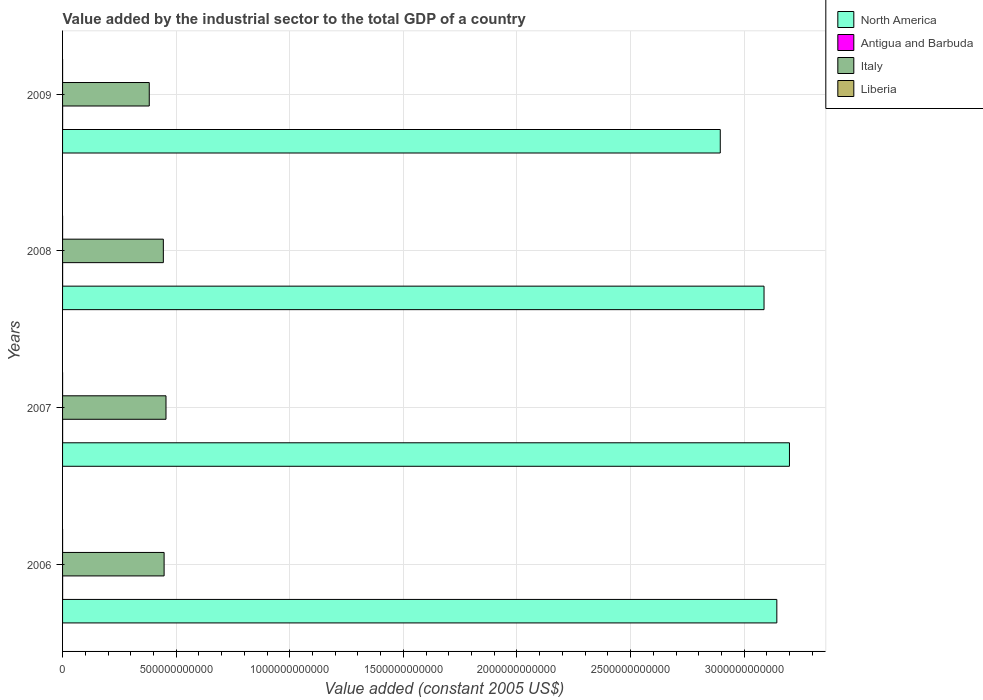How many different coloured bars are there?
Provide a short and direct response. 4. How many groups of bars are there?
Give a very brief answer. 4. Are the number of bars per tick equal to the number of legend labels?
Give a very brief answer. Yes. Are the number of bars on each tick of the Y-axis equal?
Your answer should be very brief. Yes. How many bars are there on the 1st tick from the top?
Make the answer very short. 4. What is the label of the 3rd group of bars from the top?
Offer a terse response. 2007. In how many cases, is the number of bars for a given year not equal to the number of legend labels?
Give a very brief answer. 0. What is the value added by the industrial sector in Liberia in 2009?
Your response must be concise. 5.75e+07. Across all years, what is the maximum value added by the industrial sector in Liberia?
Offer a very short reply. 6.25e+07. Across all years, what is the minimum value added by the industrial sector in Italy?
Ensure brevity in your answer.  3.82e+11. What is the total value added by the industrial sector in Liberia in the graph?
Offer a terse response. 2.19e+08. What is the difference between the value added by the industrial sector in North America in 2006 and that in 2009?
Your response must be concise. 2.49e+11. What is the difference between the value added by the industrial sector in Antigua and Barbuda in 2008 and the value added by the industrial sector in North America in 2007?
Make the answer very short. -3.20e+12. What is the average value added by the industrial sector in Italy per year?
Give a very brief answer. 4.32e+11. In the year 2006, what is the difference between the value added by the industrial sector in Antigua and Barbuda and value added by the industrial sector in Italy?
Give a very brief answer. -4.47e+11. In how many years, is the value added by the industrial sector in North America greater than 2400000000000 US$?
Keep it short and to the point. 4. What is the ratio of the value added by the industrial sector in Italy in 2007 to that in 2008?
Make the answer very short. 1.03. What is the difference between the highest and the second highest value added by the industrial sector in Antigua and Barbuda?
Make the answer very short. 7.64e+05. What is the difference between the highest and the lowest value added by the industrial sector in Italy?
Ensure brevity in your answer.  7.36e+1. In how many years, is the value added by the industrial sector in Italy greater than the average value added by the industrial sector in Italy taken over all years?
Provide a short and direct response. 3. What does the 1st bar from the top in 2008 represents?
Ensure brevity in your answer.  Liberia. What does the 3rd bar from the bottom in 2008 represents?
Your answer should be compact. Italy. How many bars are there?
Your response must be concise. 16. What is the difference between two consecutive major ticks on the X-axis?
Keep it short and to the point. 5.00e+11. Where does the legend appear in the graph?
Make the answer very short. Top right. What is the title of the graph?
Give a very brief answer. Value added by the industrial sector to the total GDP of a country. What is the label or title of the X-axis?
Your answer should be compact. Value added (constant 2005 US$). What is the label or title of the Y-axis?
Keep it short and to the point. Years. What is the Value added (constant 2005 US$) of North America in 2006?
Ensure brevity in your answer.  3.14e+12. What is the Value added (constant 2005 US$) of Antigua and Barbuda in 2006?
Ensure brevity in your answer.  2.01e+08. What is the Value added (constant 2005 US$) in Italy in 2006?
Make the answer very short. 4.47e+11. What is the Value added (constant 2005 US$) of Liberia in 2006?
Provide a short and direct response. 4.59e+07. What is the Value added (constant 2005 US$) of North America in 2007?
Make the answer very short. 3.20e+12. What is the Value added (constant 2005 US$) of Antigua and Barbuda in 2007?
Offer a very short reply. 2.17e+08. What is the Value added (constant 2005 US$) in Italy in 2007?
Make the answer very short. 4.55e+11. What is the Value added (constant 2005 US$) of Liberia in 2007?
Provide a succinct answer. 5.27e+07. What is the Value added (constant 2005 US$) of North America in 2008?
Provide a succinct answer. 3.09e+12. What is the Value added (constant 2005 US$) in Antigua and Barbuda in 2008?
Ensure brevity in your answer.  2.18e+08. What is the Value added (constant 2005 US$) in Italy in 2008?
Your answer should be very brief. 4.44e+11. What is the Value added (constant 2005 US$) in Liberia in 2008?
Ensure brevity in your answer.  6.25e+07. What is the Value added (constant 2005 US$) in North America in 2009?
Give a very brief answer. 2.89e+12. What is the Value added (constant 2005 US$) in Antigua and Barbuda in 2009?
Ensure brevity in your answer.  2.03e+08. What is the Value added (constant 2005 US$) in Italy in 2009?
Ensure brevity in your answer.  3.82e+11. What is the Value added (constant 2005 US$) of Liberia in 2009?
Give a very brief answer. 5.75e+07. Across all years, what is the maximum Value added (constant 2005 US$) in North America?
Provide a short and direct response. 3.20e+12. Across all years, what is the maximum Value added (constant 2005 US$) in Antigua and Barbuda?
Offer a terse response. 2.18e+08. Across all years, what is the maximum Value added (constant 2005 US$) of Italy?
Give a very brief answer. 4.55e+11. Across all years, what is the maximum Value added (constant 2005 US$) in Liberia?
Provide a short and direct response. 6.25e+07. Across all years, what is the minimum Value added (constant 2005 US$) in North America?
Your answer should be very brief. 2.89e+12. Across all years, what is the minimum Value added (constant 2005 US$) of Antigua and Barbuda?
Make the answer very short. 2.01e+08. Across all years, what is the minimum Value added (constant 2005 US$) of Italy?
Provide a short and direct response. 3.82e+11. Across all years, what is the minimum Value added (constant 2005 US$) of Liberia?
Your response must be concise. 4.59e+07. What is the total Value added (constant 2005 US$) in North America in the graph?
Offer a terse response. 1.23e+13. What is the total Value added (constant 2005 US$) in Antigua and Barbuda in the graph?
Give a very brief answer. 8.40e+08. What is the total Value added (constant 2005 US$) of Italy in the graph?
Your answer should be very brief. 1.73e+12. What is the total Value added (constant 2005 US$) of Liberia in the graph?
Your response must be concise. 2.19e+08. What is the difference between the Value added (constant 2005 US$) in North America in 2006 and that in 2007?
Keep it short and to the point. -5.56e+1. What is the difference between the Value added (constant 2005 US$) of Antigua and Barbuda in 2006 and that in 2007?
Ensure brevity in your answer.  -1.63e+07. What is the difference between the Value added (constant 2005 US$) of Italy in 2006 and that in 2007?
Provide a succinct answer. -8.29e+09. What is the difference between the Value added (constant 2005 US$) in Liberia in 2006 and that in 2007?
Provide a short and direct response. -6.78e+06. What is the difference between the Value added (constant 2005 US$) in North America in 2006 and that in 2008?
Your answer should be very brief. 5.63e+1. What is the difference between the Value added (constant 2005 US$) of Antigua and Barbuda in 2006 and that in 2008?
Offer a terse response. -1.71e+07. What is the difference between the Value added (constant 2005 US$) of Italy in 2006 and that in 2008?
Your answer should be compact. 3.36e+09. What is the difference between the Value added (constant 2005 US$) in Liberia in 2006 and that in 2008?
Your response must be concise. -1.66e+07. What is the difference between the Value added (constant 2005 US$) of North America in 2006 and that in 2009?
Offer a terse response. 2.49e+11. What is the difference between the Value added (constant 2005 US$) in Antigua and Barbuda in 2006 and that in 2009?
Provide a succinct answer. -2.17e+06. What is the difference between the Value added (constant 2005 US$) of Italy in 2006 and that in 2009?
Ensure brevity in your answer.  6.54e+1. What is the difference between the Value added (constant 2005 US$) of Liberia in 2006 and that in 2009?
Provide a succinct answer. -1.16e+07. What is the difference between the Value added (constant 2005 US$) in North America in 2007 and that in 2008?
Offer a terse response. 1.12e+11. What is the difference between the Value added (constant 2005 US$) in Antigua and Barbuda in 2007 and that in 2008?
Provide a succinct answer. -7.64e+05. What is the difference between the Value added (constant 2005 US$) of Italy in 2007 and that in 2008?
Your answer should be very brief. 1.17e+1. What is the difference between the Value added (constant 2005 US$) in Liberia in 2007 and that in 2008?
Offer a terse response. -9.85e+06. What is the difference between the Value added (constant 2005 US$) in North America in 2007 and that in 2009?
Give a very brief answer. 3.05e+11. What is the difference between the Value added (constant 2005 US$) of Antigua and Barbuda in 2007 and that in 2009?
Provide a short and direct response. 1.41e+07. What is the difference between the Value added (constant 2005 US$) in Italy in 2007 and that in 2009?
Your answer should be very brief. 7.36e+1. What is the difference between the Value added (constant 2005 US$) in Liberia in 2007 and that in 2009?
Provide a succinct answer. -4.80e+06. What is the difference between the Value added (constant 2005 US$) in North America in 2008 and that in 2009?
Keep it short and to the point. 1.93e+11. What is the difference between the Value added (constant 2005 US$) in Antigua and Barbuda in 2008 and that in 2009?
Your answer should be very brief. 1.49e+07. What is the difference between the Value added (constant 2005 US$) in Italy in 2008 and that in 2009?
Offer a terse response. 6.20e+1. What is the difference between the Value added (constant 2005 US$) of Liberia in 2008 and that in 2009?
Your response must be concise. 5.05e+06. What is the difference between the Value added (constant 2005 US$) of North America in 2006 and the Value added (constant 2005 US$) of Antigua and Barbuda in 2007?
Provide a succinct answer. 3.14e+12. What is the difference between the Value added (constant 2005 US$) of North America in 2006 and the Value added (constant 2005 US$) of Italy in 2007?
Give a very brief answer. 2.69e+12. What is the difference between the Value added (constant 2005 US$) of North America in 2006 and the Value added (constant 2005 US$) of Liberia in 2007?
Give a very brief answer. 3.14e+12. What is the difference between the Value added (constant 2005 US$) of Antigua and Barbuda in 2006 and the Value added (constant 2005 US$) of Italy in 2007?
Provide a short and direct response. -4.55e+11. What is the difference between the Value added (constant 2005 US$) in Antigua and Barbuda in 2006 and the Value added (constant 2005 US$) in Liberia in 2007?
Ensure brevity in your answer.  1.48e+08. What is the difference between the Value added (constant 2005 US$) in Italy in 2006 and the Value added (constant 2005 US$) in Liberia in 2007?
Offer a very short reply. 4.47e+11. What is the difference between the Value added (constant 2005 US$) in North America in 2006 and the Value added (constant 2005 US$) in Antigua and Barbuda in 2008?
Your response must be concise. 3.14e+12. What is the difference between the Value added (constant 2005 US$) of North America in 2006 and the Value added (constant 2005 US$) of Italy in 2008?
Your response must be concise. 2.70e+12. What is the difference between the Value added (constant 2005 US$) in North America in 2006 and the Value added (constant 2005 US$) in Liberia in 2008?
Your response must be concise. 3.14e+12. What is the difference between the Value added (constant 2005 US$) of Antigua and Barbuda in 2006 and the Value added (constant 2005 US$) of Italy in 2008?
Your answer should be very brief. -4.43e+11. What is the difference between the Value added (constant 2005 US$) of Antigua and Barbuda in 2006 and the Value added (constant 2005 US$) of Liberia in 2008?
Offer a very short reply. 1.39e+08. What is the difference between the Value added (constant 2005 US$) of Italy in 2006 and the Value added (constant 2005 US$) of Liberia in 2008?
Offer a very short reply. 4.47e+11. What is the difference between the Value added (constant 2005 US$) of North America in 2006 and the Value added (constant 2005 US$) of Antigua and Barbuda in 2009?
Keep it short and to the point. 3.14e+12. What is the difference between the Value added (constant 2005 US$) of North America in 2006 and the Value added (constant 2005 US$) of Italy in 2009?
Your answer should be very brief. 2.76e+12. What is the difference between the Value added (constant 2005 US$) of North America in 2006 and the Value added (constant 2005 US$) of Liberia in 2009?
Keep it short and to the point. 3.14e+12. What is the difference between the Value added (constant 2005 US$) of Antigua and Barbuda in 2006 and the Value added (constant 2005 US$) of Italy in 2009?
Provide a short and direct response. -3.81e+11. What is the difference between the Value added (constant 2005 US$) in Antigua and Barbuda in 2006 and the Value added (constant 2005 US$) in Liberia in 2009?
Provide a succinct answer. 1.44e+08. What is the difference between the Value added (constant 2005 US$) of Italy in 2006 and the Value added (constant 2005 US$) of Liberia in 2009?
Offer a terse response. 4.47e+11. What is the difference between the Value added (constant 2005 US$) in North America in 2007 and the Value added (constant 2005 US$) in Antigua and Barbuda in 2008?
Provide a succinct answer. 3.20e+12. What is the difference between the Value added (constant 2005 US$) of North America in 2007 and the Value added (constant 2005 US$) of Italy in 2008?
Offer a very short reply. 2.76e+12. What is the difference between the Value added (constant 2005 US$) in North America in 2007 and the Value added (constant 2005 US$) in Liberia in 2008?
Your answer should be very brief. 3.20e+12. What is the difference between the Value added (constant 2005 US$) in Antigua and Barbuda in 2007 and the Value added (constant 2005 US$) in Italy in 2008?
Your response must be concise. -4.43e+11. What is the difference between the Value added (constant 2005 US$) of Antigua and Barbuda in 2007 and the Value added (constant 2005 US$) of Liberia in 2008?
Ensure brevity in your answer.  1.55e+08. What is the difference between the Value added (constant 2005 US$) in Italy in 2007 and the Value added (constant 2005 US$) in Liberia in 2008?
Offer a terse response. 4.55e+11. What is the difference between the Value added (constant 2005 US$) of North America in 2007 and the Value added (constant 2005 US$) of Antigua and Barbuda in 2009?
Offer a very short reply. 3.20e+12. What is the difference between the Value added (constant 2005 US$) in North America in 2007 and the Value added (constant 2005 US$) in Italy in 2009?
Keep it short and to the point. 2.82e+12. What is the difference between the Value added (constant 2005 US$) of North America in 2007 and the Value added (constant 2005 US$) of Liberia in 2009?
Provide a succinct answer. 3.20e+12. What is the difference between the Value added (constant 2005 US$) in Antigua and Barbuda in 2007 and the Value added (constant 2005 US$) in Italy in 2009?
Ensure brevity in your answer.  -3.81e+11. What is the difference between the Value added (constant 2005 US$) of Antigua and Barbuda in 2007 and the Value added (constant 2005 US$) of Liberia in 2009?
Give a very brief answer. 1.60e+08. What is the difference between the Value added (constant 2005 US$) in Italy in 2007 and the Value added (constant 2005 US$) in Liberia in 2009?
Ensure brevity in your answer.  4.55e+11. What is the difference between the Value added (constant 2005 US$) in North America in 2008 and the Value added (constant 2005 US$) in Antigua and Barbuda in 2009?
Your response must be concise. 3.09e+12. What is the difference between the Value added (constant 2005 US$) in North America in 2008 and the Value added (constant 2005 US$) in Italy in 2009?
Provide a succinct answer. 2.71e+12. What is the difference between the Value added (constant 2005 US$) of North America in 2008 and the Value added (constant 2005 US$) of Liberia in 2009?
Offer a terse response. 3.09e+12. What is the difference between the Value added (constant 2005 US$) of Antigua and Barbuda in 2008 and the Value added (constant 2005 US$) of Italy in 2009?
Your answer should be very brief. -3.81e+11. What is the difference between the Value added (constant 2005 US$) of Antigua and Barbuda in 2008 and the Value added (constant 2005 US$) of Liberia in 2009?
Your response must be concise. 1.61e+08. What is the difference between the Value added (constant 2005 US$) of Italy in 2008 and the Value added (constant 2005 US$) of Liberia in 2009?
Your response must be concise. 4.44e+11. What is the average Value added (constant 2005 US$) in North America per year?
Provide a short and direct response. 3.08e+12. What is the average Value added (constant 2005 US$) of Antigua and Barbuda per year?
Your answer should be very brief. 2.10e+08. What is the average Value added (constant 2005 US$) of Italy per year?
Provide a short and direct response. 4.32e+11. What is the average Value added (constant 2005 US$) of Liberia per year?
Your answer should be very brief. 5.47e+07. In the year 2006, what is the difference between the Value added (constant 2005 US$) in North America and Value added (constant 2005 US$) in Antigua and Barbuda?
Offer a very short reply. 3.14e+12. In the year 2006, what is the difference between the Value added (constant 2005 US$) in North America and Value added (constant 2005 US$) in Italy?
Keep it short and to the point. 2.70e+12. In the year 2006, what is the difference between the Value added (constant 2005 US$) of North America and Value added (constant 2005 US$) of Liberia?
Give a very brief answer. 3.14e+12. In the year 2006, what is the difference between the Value added (constant 2005 US$) in Antigua and Barbuda and Value added (constant 2005 US$) in Italy?
Offer a terse response. -4.47e+11. In the year 2006, what is the difference between the Value added (constant 2005 US$) of Antigua and Barbuda and Value added (constant 2005 US$) of Liberia?
Provide a succinct answer. 1.55e+08. In the year 2006, what is the difference between the Value added (constant 2005 US$) of Italy and Value added (constant 2005 US$) of Liberia?
Provide a succinct answer. 4.47e+11. In the year 2007, what is the difference between the Value added (constant 2005 US$) of North America and Value added (constant 2005 US$) of Antigua and Barbuda?
Offer a terse response. 3.20e+12. In the year 2007, what is the difference between the Value added (constant 2005 US$) of North America and Value added (constant 2005 US$) of Italy?
Ensure brevity in your answer.  2.74e+12. In the year 2007, what is the difference between the Value added (constant 2005 US$) of North America and Value added (constant 2005 US$) of Liberia?
Ensure brevity in your answer.  3.20e+12. In the year 2007, what is the difference between the Value added (constant 2005 US$) in Antigua and Barbuda and Value added (constant 2005 US$) in Italy?
Offer a very short reply. -4.55e+11. In the year 2007, what is the difference between the Value added (constant 2005 US$) of Antigua and Barbuda and Value added (constant 2005 US$) of Liberia?
Your answer should be compact. 1.65e+08. In the year 2007, what is the difference between the Value added (constant 2005 US$) in Italy and Value added (constant 2005 US$) in Liberia?
Your answer should be very brief. 4.55e+11. In the year 2008, what is the difference between the Value added (constant 2005 US$) of North America and Value added (constant 2005 US$) of Antigua and Barbuda?
Provide a succinct answer. 3.09e+12. In the year 2008, what is the difference between the Value added (constant 2005 US$) of North America and Value added (constant 2005 US$) of Italy?
Ensure brevity in your answer.  2.64e+12. In the year 2008, what is the difference between the Value added (constant 2005 US$) in North America and Value added (constant 2005 US$) in Liberia?
Your answer should be very brief. 3.09e+12. In the year 2008, what is the difference between the Value added (constant 2005 US$) of Antigua and Barbuda and Value added (constant 2005 US$) of Italy?
Offer a very short reply. -4.43e+11. In the year 2008, what is the difference between the Value added (constant 2005 US$) in Antigua and Barbuda and Value added (constant 2005 US$) in Liberia?
Your response must be concise. 1.56e+08. In the year 2008, what is the difference between the Value added (constant 2005 US$) in Italy and Value added (constant 2005 US$) in Liberia?
Make the answer very short. 4.44e+11. In the year 2009, what is the difference between the Value added (constant 2005 US$) of North America and Value added (constant 2005 US$) of Antigua and Barbuda?
Your response must be concise. 2.89e+12. In the year 2009, what is the difference between the Value added (constant 2005 US$) of North America and Value added (constant 2005 US$) of Italy?
Provide a succinct answer. 2.51e+12. In the year 2009, what is the difference between the Value added (constant 2005 US$) in North America and Value added (constant 2005 US$) in Liberia?
Offer a terse response. 2.89e+12. In the year 2009, what is the difference between the Value added (constant 2005 US$) in Antigua and Barbuda and Value added (constant 2005 US$) in Italy?
Provide a succinct answer. -3.81e+11. In the year 2009, what is the difference between the Value added (constant 2005 US$) of Antigua and Barbuda and Value added (constant 2005 US$) of Liberia?
Provide a short and direct response. 1.46e+08. In the year 2009, what is the difference between the Value added (constant 2005 US$) in Italy and Value added (constant 2005 US$) in Liberia?
Your response must be concise. 3.82e+11. What is the ratio of the Value added (constant 2005 US$) of North America in 2006 to that in 2007?
Give a very brief answer. 0.98. What is the ratio of the Value added (constant 2005 US$) in Antigua and Barbuda in 2006 to that in 2007?
Provide a short and direct response. 0.93. What is the ratio of the Value added (constant 2005 US$) in Italy in 2006 to that in 2007?
Provide a succinct answer. 0.98. What is the ratio of the Value added (constant 2005 US$) in Liberia in 2006 to that in 2007?
Your answer should be very brief. 0.87. What is the ratio of the Value added (constant 2005 US$) in North America in 2006 to that in 2008?
Provide a succinct answer. 1.02. What is the ratio of the Value added (constant 2005 US$) of Antigua and Barbuda in 2006 to that in 2008?
Provide a short and direct response. 0.92. What is the ratio of the Value added (constant 2005 US$) of Italy in 2006 to that in 2008?
Provide a short and direct response. 1.01. What is the ratio of the Value added (constant 2005 US$) in Liberia in 2006 to that in 2008?
Your response must be concise. 0.73. What is the ratio of the Value added (constant 2005 US$) of North America in 2006 to that in 2009?
Make the answer very short. 1.09. What is the ratio of the Value added (constant 2005 US$) of Antigua and Barbuda in 2006 to that in 2009?
Make the answer very short. 0.99. What is the ratio of the Value added (constant 2005 US$) in Italy in 2006 to that in 2009?
Offer a terse response. 1.17. What is the ratio of the Value added (constant 2005 US$) in Liberia in 2006 to that in 2009?
Your answer should be very brief. 0.8. What is the ratio of the Value added (constant 2005 US$) of North America in 2007 to that in 2008?
Provide a succinct answer. 1.04. What is the ratio of the Value added (constant 2005 US$) of Italy in 2007 to that in 2008?
Keep it short and to the point. 1.03. What is the ratio of the Value added (constant 2005 US$) of Liberia in 2007 to that in 2008?
Give a very brief answer. 0.84. What is the ratio of the Value added (constant 2005 US$) of North America in 2007 to that in 2009?
Give a very brief answer. 1.11. What is the ratio of the Value added (constant 2005 US$) of Antigua and Barbuda in 2007 to that in 2009?
Offer a terse response. 1.07. What is the ratio of the Value added (constant 2005 US$) of Italy in 2007 to that in 2009?
Provide a short and direct response. 1.19. What is the ratio of the Value added (constant 2005 US$) in Liberia in 2007 to that in 2009?
Keep it short and to the point. 0.92. What is the ratio of the Value added (constant 2005 US$) of North America in 2008 to that in 2009?
Keep it short and to the point. 1.07. What is the ratio of the Value added (constant 2005 US$) in Antigua and Barbuda in 2008 to that in 2009?
Offer a very short reply. 1.07. What is the ratio of the Value added (constant 2005 US$) of Italy in 2008 to that in 2009?
Your answer should be very brief. 1.16. What is the ratio of the Value added (constant 2005 US$) in Liberia in 2008 to that in 2009?
Provide a succinct answer. 1.09. What is the difference between the highest and the second highest Value added (constant 2005 US$) in North America?
Provide a short and direct response. 5.56e+1. What is the difference between the highest and the second highest Value added (constant 2005 US$) of Antigua and Barbuda?
Offer a very short reply. 7.64e+05. What is the difference between the highest and the second highest Value added (constant 2005 US$) of Italy?
Offer a terse response. 8.29e+09. What is the difference between the highest and the second highest Value added (constant 2005 US$) of Liberia?
Provide a short and direct response. 5.05e+06. What is the difference between the highest and the lowest Value added (constant 2005 US$) in North America?
Offer a very short reply. 3.05e+11. What is the difference between the highest and the lowest Value added (constant 2005 US$) of Antigua and Barbuda?
Ensure brevity in your answer.  1.71e+07. What is the difference between the highest and the lowest Value added (constant 2005 US$) of Italy?
Give a very brief answer. 7.36e+1. What is the difference between the highest and the lowest Value added (constant 2005 US$) of Liberia?
Your answer should be very brief. 1.66e+07. 